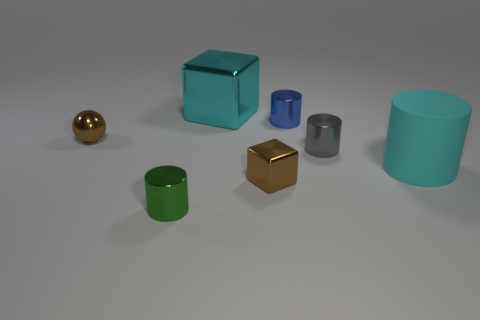There is a small object that is the same color as the small block; what is its material?
Offer a very short reply. Metal. Are there the same number of small brown cubes behind the cyan metal object and tiny purple metallic objects?
Make the answer very short. Yes. Are the tiny sphere and the blue cylinder made of the same material?
Your answer should be compact. Yes. There is a object that is both to the left of the small brown block and on the right side of the tiny green metallic cylinder; what is its size?
Offer a very short reply. Large. How many gray cylinders have the same size as the blue thing?
Provide a succinct answer. 1. How big is the brown thing that is to the left of the cylinder that is in front of the large cyan rubber thing?
Your response must be concise. Small. Do the brown thing that is to the left of the large block and the large cyan thing that is behind the blue thing have the same shape?
Your response must be concise. No. What is the color of the metal thing that is both behind the brown metallic sphere and on the right side of the cyan metal thing?
Keep it short and to the point. Blue. Are there any small cylinders of the same color as the big matte cylinder?
Your response must be concise. No. The block that is behind the tiny blue metal cylinder is what color?
Offer a terse response. Cyan. 